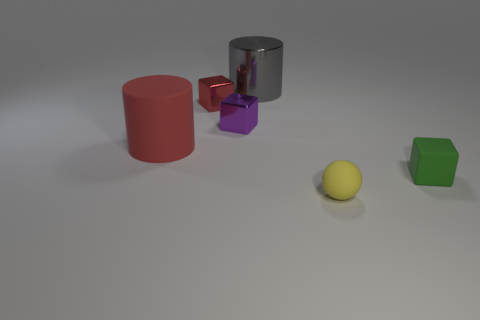Add 2 tiny things. How many objects exist? 8 Subtract all shiny cubes. How many cubes are left? 1 Subtract all gray cylinders. How many cylinders are left? 1 Subtract all balls. How many objects are left? 5 Subtract 1 cylinders. How many cylinders are left? 1 Subtract all blue spheres. Subtract all green cylinders. How many spheres are left? 1 Subtract all green blocks. How many green spheres are left? 0 Subtract all tiny cubes. Subtract all green things. How many objects are left? 2 Add 2 purple shiny things. How many purple shiny things are left? 3 Add 2 large red cylinders. How many large red cylinders exist? 3 